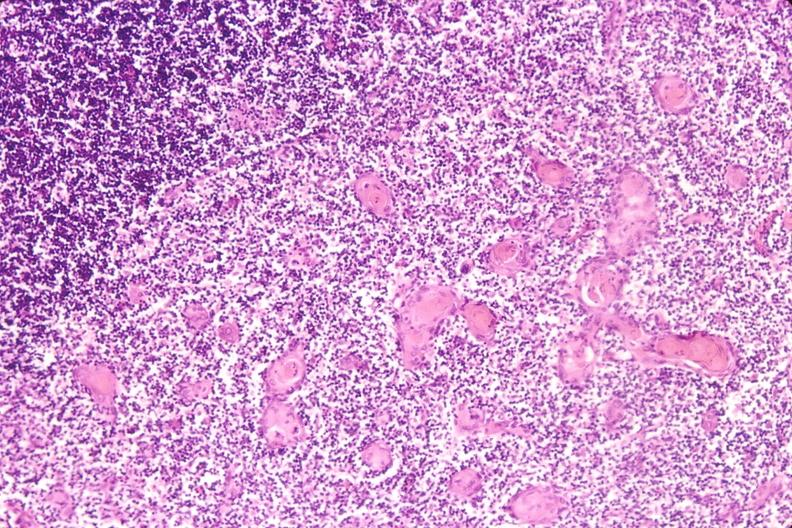do stress induce involution in baby with hyaline membrane disease?
Answer the question using a single word or phrase. Yes 